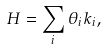Convert formula to latex. <formula><loc_0><loc_0><loc_500><loc_500>H = \sum _ { i } \theta _ { i } k _ { i } ,</formula> 